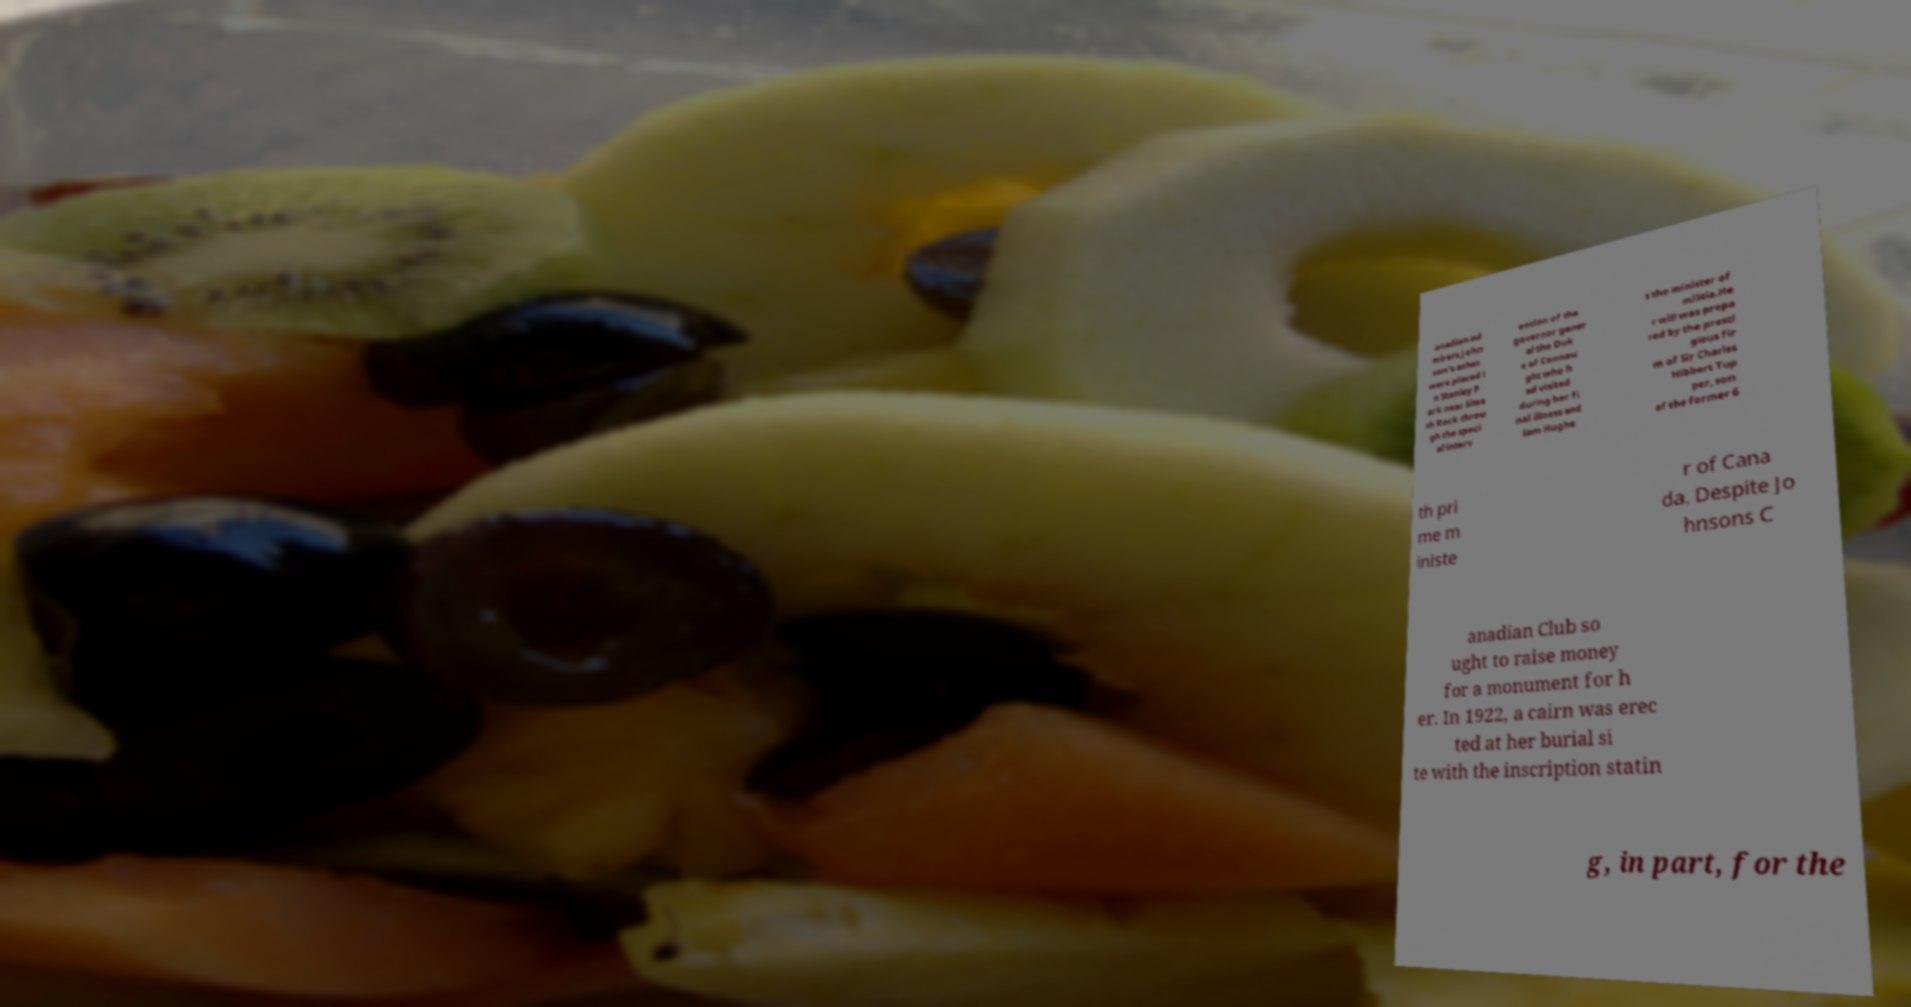Could you extract and type out the text from this image? anadian ad mirers.John son's ashes were placed i n Stanley P ark near Siwa sh Rock throu gh the speci al interv ention of the governor gener al the Duk e of Connau ght who h ad visited during her fi nal illness and Sam Hughe s the minister of militia.He r will was prepa red by the presti gious fir m of Sir Charles Hibbert Tup per, son of the former 6 th pri me m iniste r of Cana da. Despite Jo hnsons C anadian Club so ught to raise money for a monument for h er. In 1922, a cairn was erec ted at her burial si te with the inscription statin g, in part, for the 